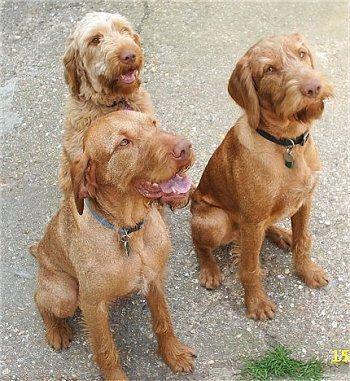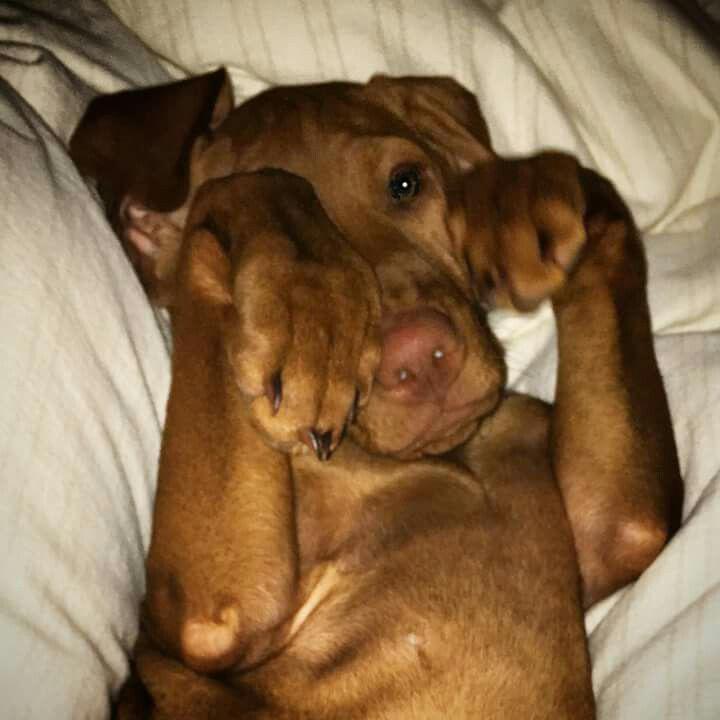The first image is the image on the left, the second image is the image on the right. Evaluate the accuracy of this statement regarding the images: "Each image contains one red-orange dog, which has its face turned forward.". Is it true? Answer yes or no. No. The first image is the image on the left, the second image is the image on the right. Examine the images to the left and right. Is the description "The dog in the image on the left is sitting on a wooden surface." accurate? Answer yes or no. No. 